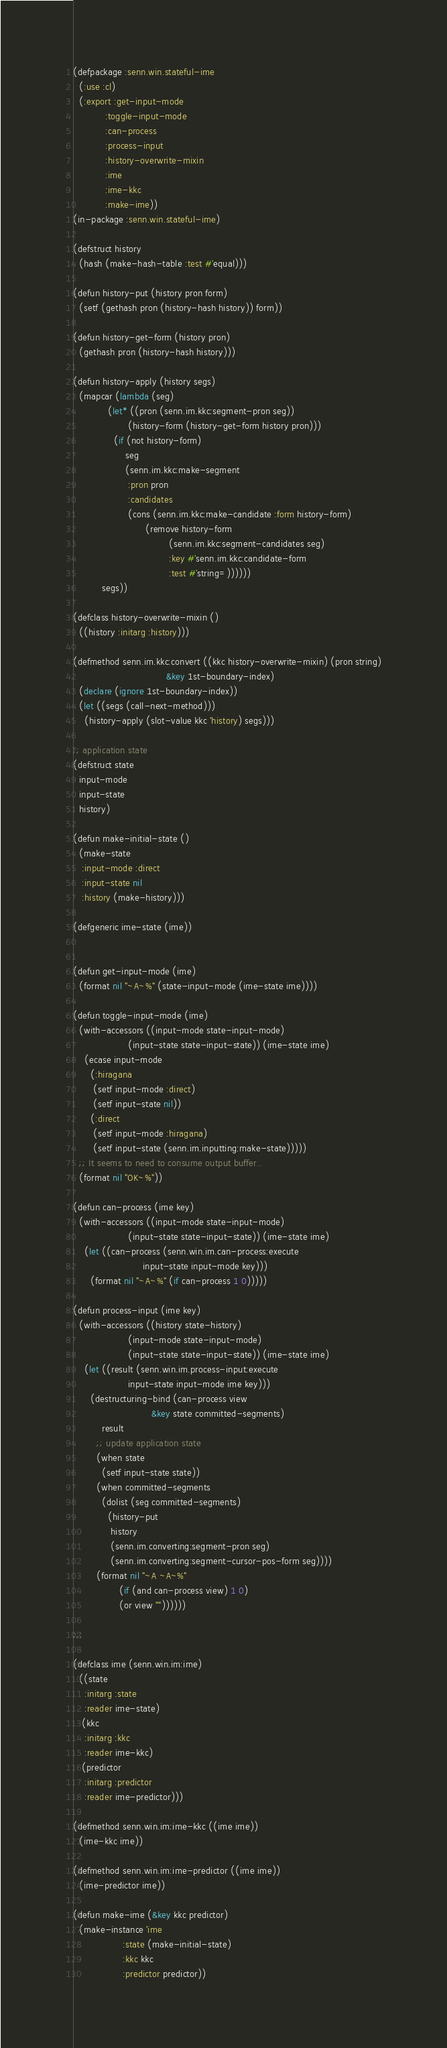<code> <loc_0><loc_0><loc_500><loc_500><_Lisp_>(defpackage :senn.win.stateful-ime
  (:use :cl)
  (:export :get-input-mode
           :toggle-input-mode
           :can-process
           :process-input
           :history-overwrite-mixin
           :ime
           :ime-kkc
           :make-ime))
(in-package :senn.win.stateful-ime)

(defstruct history
  (hash (make-hash-table :test #'equal)))

(defun history-put (history pron form)
  (setf (gethash pron (history-hash history)) form))

(defun history-get-form (history pron)
  (gethash pron (history-hash history)))

(defun history-apply (history segs)
  (mapcar (lambda (seg)
            (let* ((pron (senn.im.kkc:segment-pron seg))
                   (history-form (history-get-form history pron)))
              (if (not history-form)
                  seg
                  (senn.im.kkc:make-segment
                   :pron pron
                   :candidates
                   (cons (senn.im.kkc:make-candidate :form history-form)
                         (remove history-form
                                 (senn.im.kkc:segment-candidates seg)
                                 :key #'senn.im.kkc:candidate-form
                                 :test #'string=))))))
          segs))

(defclass history-overwrite-mixin ()
  ((history :initarg :history)))

(defmethod senn.im.kkc:convert ((kkc history-overwrite-mixin) (pron string)
                                &key 1st-boundary-index)
  (declare (ignore 1st-boundary-index))
  (let ((segs (call-next-method)))
    (history-apply (slot-value kkc 'history) segs)))

;; application state
(defstruct state
  input-mode
  input-state
  history)

(defun make-initial-state ()
  (make-state
   :input-mode :direct
   :input-state nil
   :history (make-history)))

(defgeneric ime-state (ime))


(defun get-input-mode (ime)
  (format nil "~A~%" (state-input-mode (ime-state ime))))

(defun toggle-input-mode (ime)
  (with-accessors ((input-mode state-input-mode)
                   (input-state state-input-state)) (ime-state ime)
    (ecase input-mode
      (:hiragana
       (setf input-mode :direct)
       (setf input-state nil))
      (:direct
       (setf input-mode :hiragana)
       (setf input-state (senn.im.inputting:make-state)))))
  ;; It seems to need to consume output buffer..
  (format nil "OK~%"))

(defun can-process (ime key)
  (with-accessors ((input-mode state-input-mode)
                   (input-state state-input-state)) (ime-state ime)
    (let ((can-process (senn.win.im.can-process:execute
                        input-state input-mode key)))
      (format nil "~A~%" (if can-process 1 0)))))

(defun process-input (ime key)
  (with-accessors ((history state-history)
                   (input-mode state-input-mode)
                   (input-state state-input-state)) (ime-state ime)
    (let ((result (senn.win.im.process-input:execute
                   input-state input-mode ime key)))
      (destructuring-bind (can-process view
                           &key state committed-segments)
          result
        ;; update application state
        (when state
          (setf input-state state))
        (when committed-segments
          (dolist (seg committed-segments)
            (history-put
             history
             (senn.im.converting:segment-pron seg)
             (senn.im.converting:segment-cursor-pos-form seg))))
        (format nil "~A ~A~%"
                (if (and can-process view) 1 0)
                (or view ""))))))

;;;

(defclass ime (senn.win.im:ime)
  ((state
    :initarg :state
    :reader ime-state)
   (kkc
    :initarg :kkc
    :reader ime-kkc)
   (predictor
    :initarg :predictor
    :reader ime-predictor)))

(defmethod senn.win.im:ime-kkc ((ime ime))
  (ime-kkc ime))

(defmethod senn.win.im:ime-predictor ((ime ime))
  (ime-predictor ime))

(defun make-ime (&key kkc predictor)
  (make-instance 'ime
                 :state (make-initial-state)
                 :kkc kkc
                 :predictor predictor))
</code> 